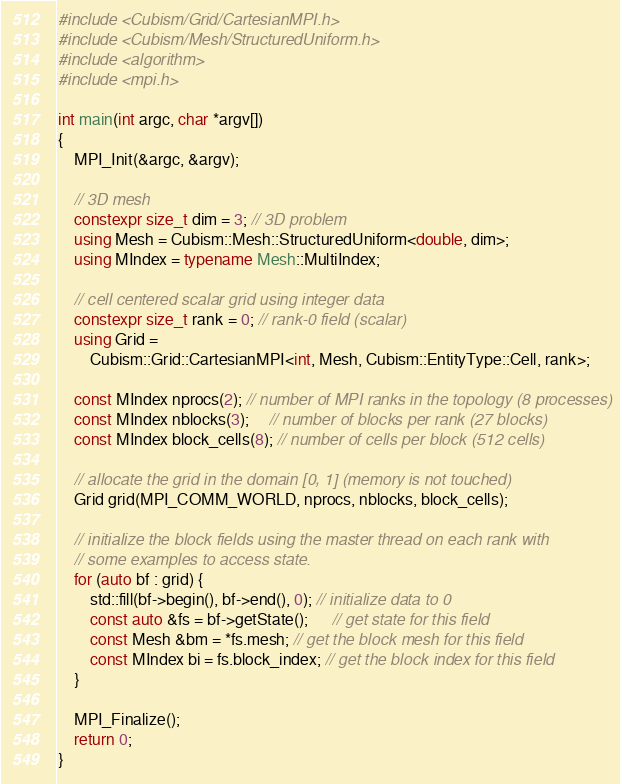<code> <loc_0><loc_0><loc_500><loc_500><_C++_>#include <Cubism/Grid/CartesianMPI.h>
#include <Cubism/Mesh/StructuredUniform.h>
#include <algorithm>
#include <mpi.h>

int main(int argc, char *argv[])
{
    MPI_Init(&argc, &argv);

    // 3D mesh
    constexpr size_t dim = 3; // 3D problem
    using Mesh = Cubism::Mesh::StructuredUniform<double, dim>;
    using MIndex = typename Mesh::MultiIndex;

    // cell centered scalar grid using integer data
    constexpr size_t rank = 0; // rank-0 field (scalar)
    using Grid =
        Cubism::Grid::CartesianMPI<int, Mesh, Cubism::EntityType::Cell, rank>;

    const MIndex nprocs(2); // number of MPI ranks in the topology (8 processes)
    const MIndex nblocks(3);     // number of blocks per rank (27 blocks)
    const MIndex block_cells(8); // number of cells per block (512 cells)

    // allocate the grid in the domain [0, 1] (memory is not touched)
    Grid grid(MPI_COMM_WORLD, nprocs, nblocks, block_cells);

    // initialize the block fields using the master thread on each rank with
    // some examples to access state.
    for (auto bf : grid) {
        std::fill(bf->begin(), bf->end(), 0); // initialize data to 0
        const auto &fs = bf->getState();      // get state for this field
        const Mesh &bm = *fs.mesh; // get the block mesh for this field
        const MIndex bi = fs.block_index; // get the block index for this field
    }

    MPI_Finalize();
    return 0;
}
</code> 